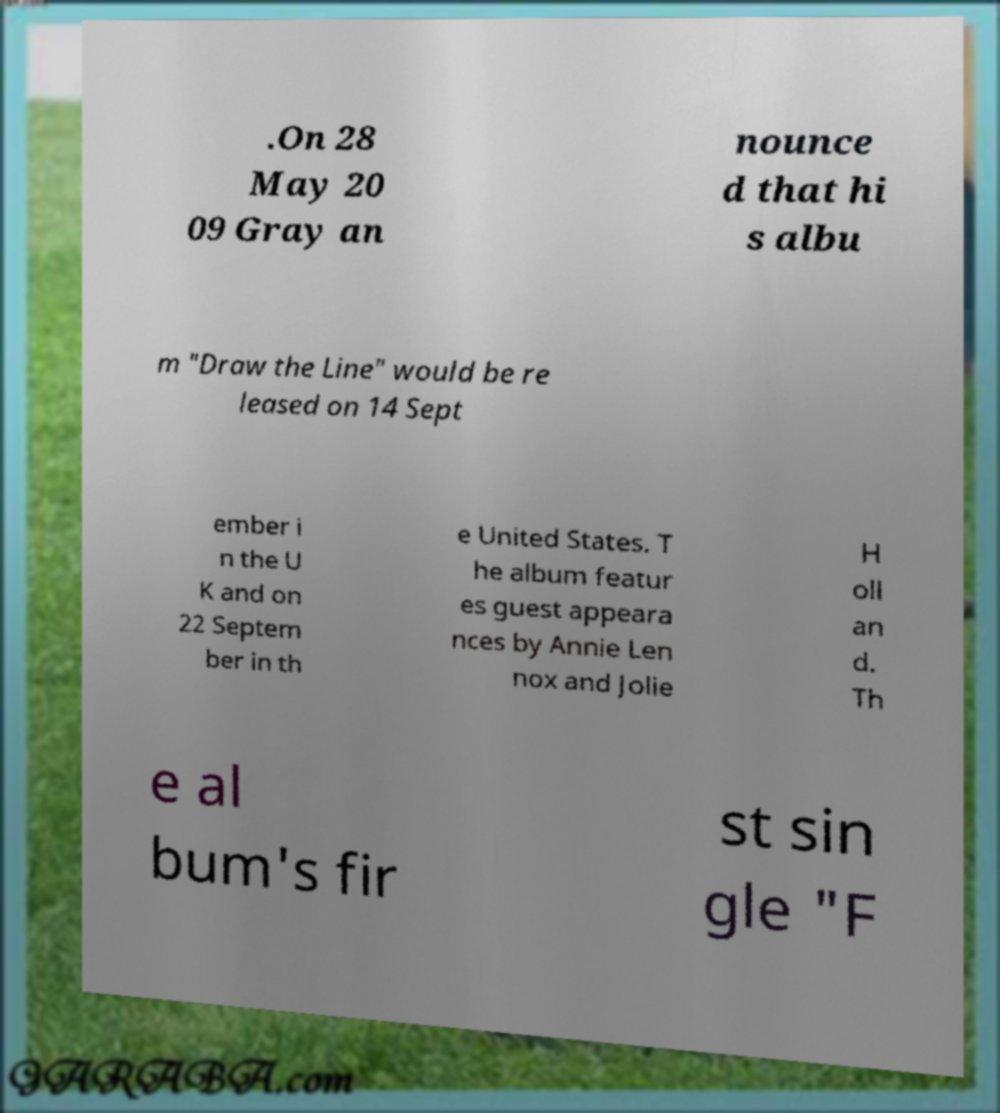For documentation purposes, I need the text within this image transcribed. Could you provide that? .On 28 May 20 09 Gray an nounce d that hi s albu m "Draw the Line" would be re leased on 14 Sept ember i n the U K and on 22 Septem ber in th e United States. T he album featur es guest appeara nces by Annie Len nox and Jolie H oll an d. Th e al bum's fir st sin gle "F 